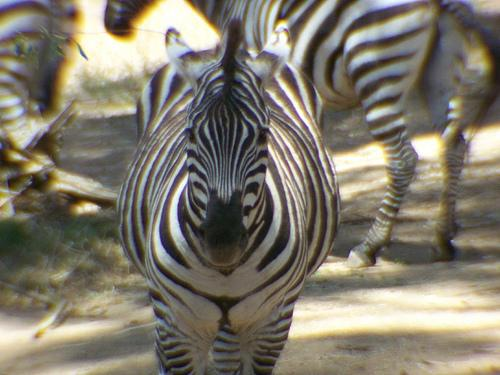Please verbally depict the primary animal in the image and its actions. A zebra is walking and standing in the picture with striped legs, dark nose, and various black stripes on its body. Give a summary of the zebra's body features in the image. The zebra has a dark nose, striped legs, black stripes, and its eyes, ears, tail, mane, and front legs are visible. What are the objects mentioned that relate directly to the zebra's features? Nose, eyes, tail, ears, mane, striped leg, and black stripes. Enumerate the captions related to the zebra's body parts. Dark nose, striped leg, black stripes, eyes, tail, ears, mane, and front legs. How many animals are present in the image, and what are they doing? One zebra is present, and it is walking and standing. Analyze how the objects in the image are interacting. The zebra is standing on the ground with a shadow beneath it, interacting with the sticks and hoof on the ground. Which captions are related to objects on the ground? Sticks, hoof, ground beneath the zebra, and shadow. Identify the sentiment portrayed in the image and elaborate. The image portrays a neutral sentiment, showing a zebra peacefully walking and standing in its natural habitat. What is the state of the zebra in the image? The zebra is walking and standing. What can you tell me about the zebra's environment in the picture? There are sticks on the ground, grass in the background, and the zebra is standing on the ground with a shadow. Does the zebra have a blue nose? The zebra's nose is described as dark, not blue. Is the zebra's mane bright yellow? There is no mention of the color of the zebra's mane, but it's highly unlikely to be bright yellow, given the natural coloration of zebras. Can you see a tree behind the zebra? The only background element mentioned is grass, not a tree. Are the sticks floating in the air above the zebra? The sticks are described to be on the ground or on the zebra, not floating in the air. Is the zebra flying in the sky? The zebra is clearly described as either walking or standing, not flying. Can you find the pink stripe on the zebra? All the mentioned stripes are described as black, not pink.  